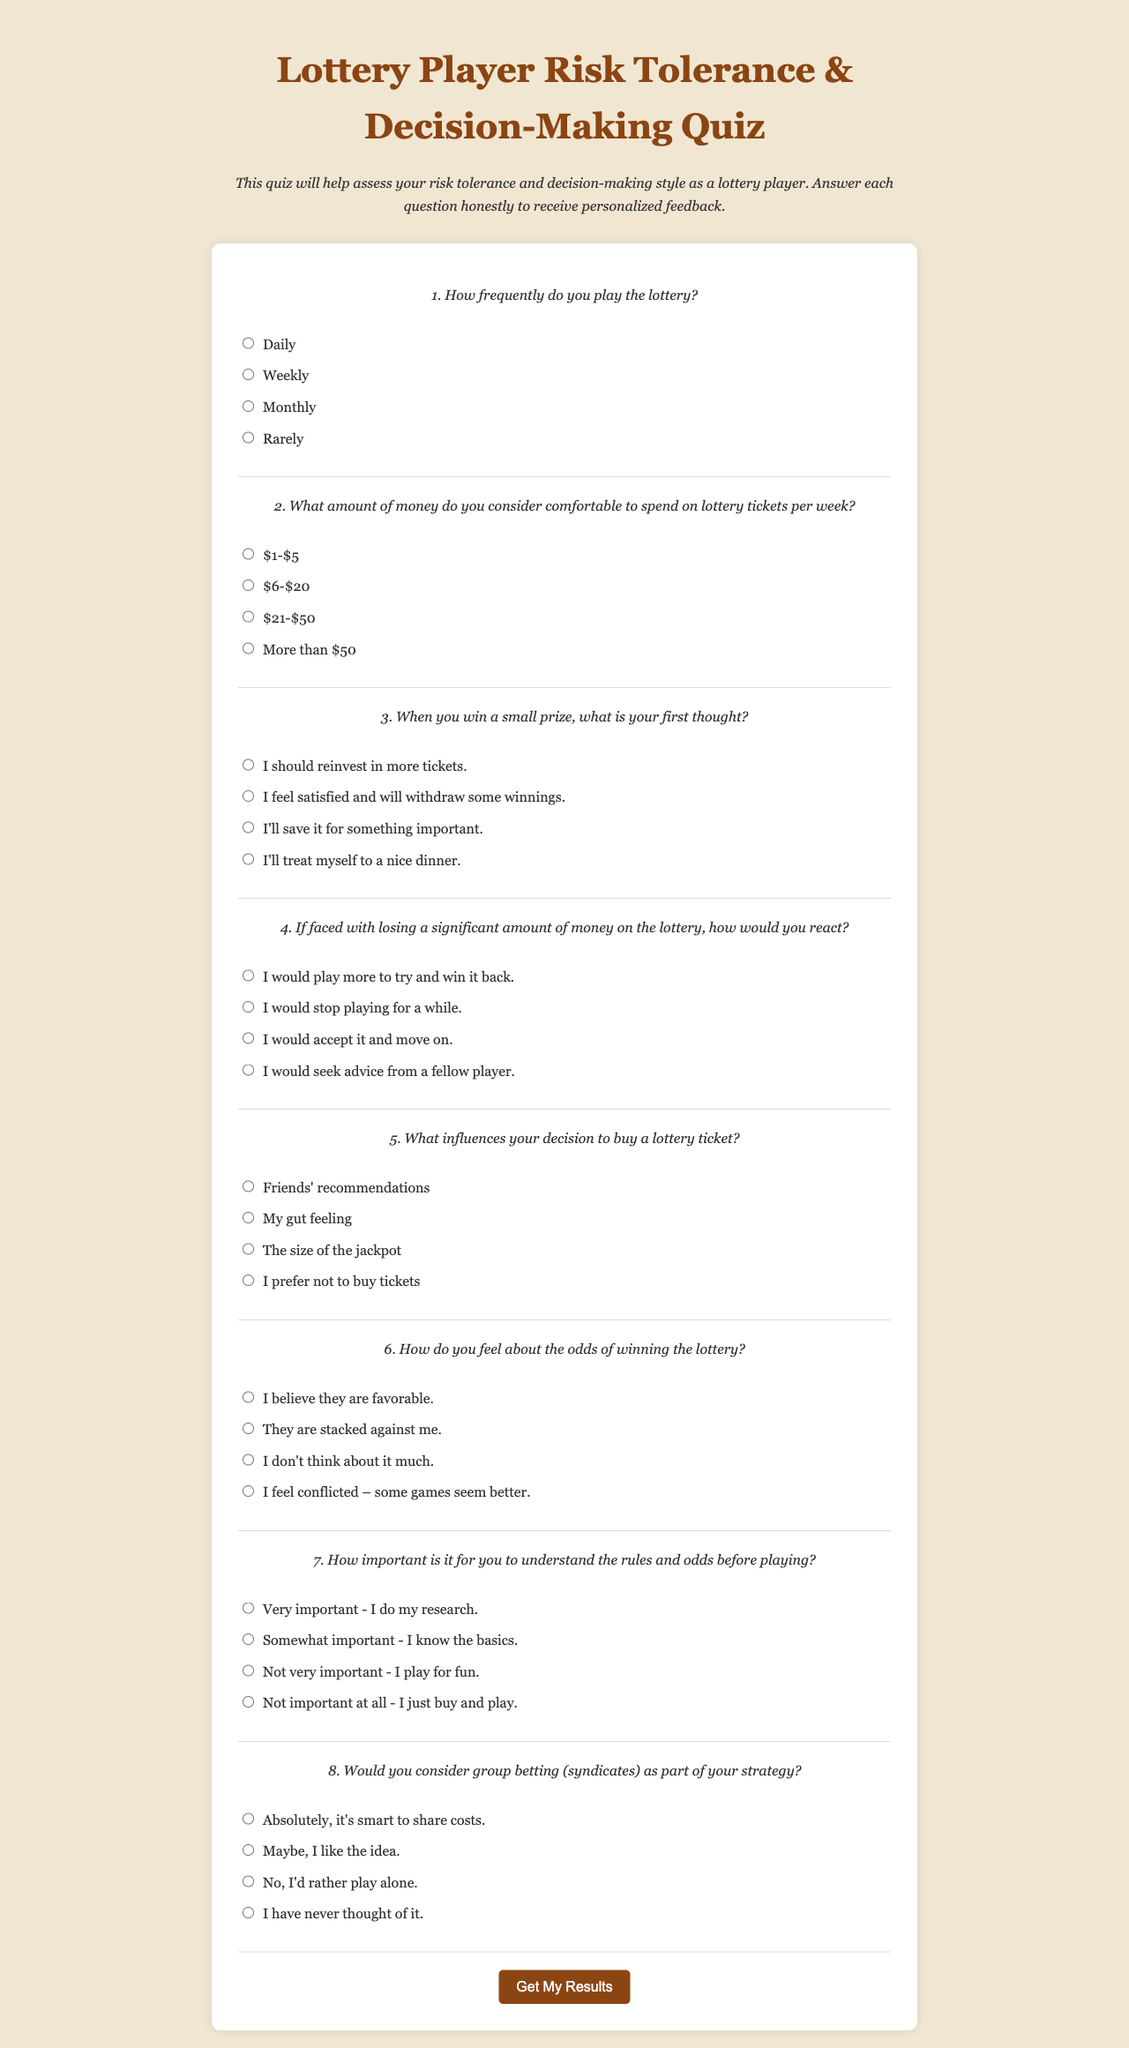What is the title of the quiz? The title of the quiz is prominently displayed at the top of the document.
Answer: Lottery Player Risk Tolerance & Decision-Making Quiz How many questions are in the quiz? The quiz consists of eight questions, as indicated by the structure of the form.
Answer: 8 What is the lowest score a participant can achieve? The lowest score is calculated based on the lowest values assigned to the answer choices in the quiz.
Answer: 0 What does a score of 0-10 indicate? The feedback for this score range is provided at the end of the document based on the scoring system.
Answer: Low risk tolerance Which frequency option suggests a person plays daily? The frequency choices are based on the descriptions given next to the radio button selections in the quiz.
Answer: Daily What is one of the options for how much a participant is comfortable spending on tickets? The options are outlined in the second question of the quiz regarding spending habits.
Answer: $1-$5 What might a high-risk tolerance player do after experiencing significant losses? This reflects the reasoning behind the typical behaviors described in the feedback section when players have high risk tolerance.
Answer: Play more What color is the background of the quiz form? The background color can be determined by analyzing the CSS styling in the document.
Answer: #f0e6d2 